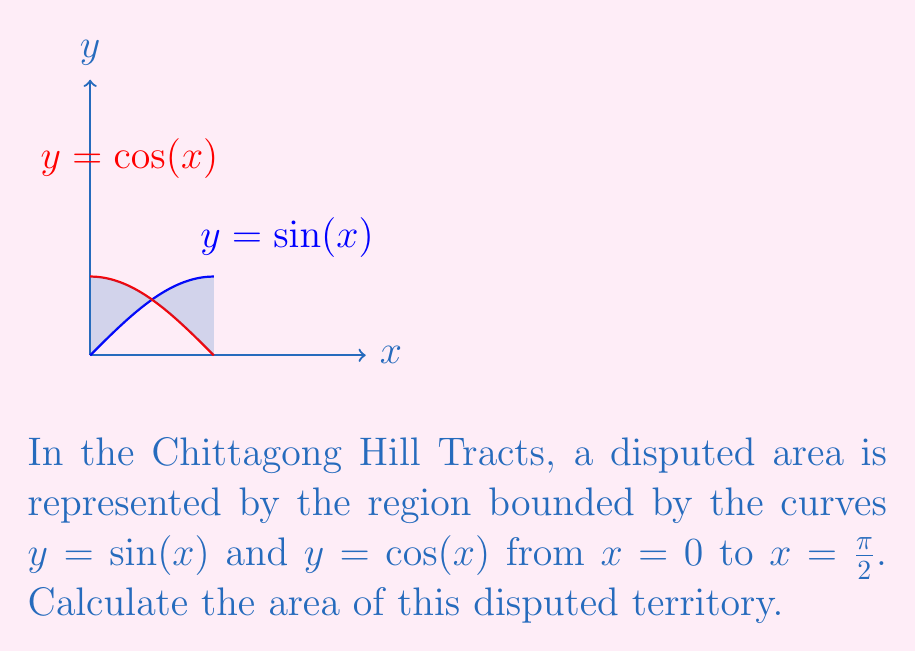Give your solution to this math problem. To find the area of the disputed territory, we need to calculate the definite integral of the difference between the two functions from 0 to $\frac{\pi}{2}$:

1) The area is given by:
   $$A = \int_0^{\frac{\pi}{2}} [\sin(x) - \cos(x)] dx$$

2) To evaluate this integral, we can use the antiderivatives:
   $$\int \sin(x) dx = -\cos(x) + C$$
   $$\int \cos(x) dx = \sin(x) + C$$

3) Applying the Fundamental Theorem of Calculus:
   $$A = [-\cos(x) - \sin(x)]_0^{\frac{\pi}{2}}$$

4) Evaluate at the limits:
   $$A = [-\cos(\frac{\pi}{2}) - \sin(\frac{\pi}{2})] - [-\cos(0) - \sin(0)]$$

5) Simplify:
   $$A = [0 - 1] - [-1 - 0] = -1 + 1 = 0$$

The area evaluates to zero because the regions where $\sin(x)$ is greater than $\cos(x)$ and where $\cos(x)$ is greater than $\sin(x)$ are equal and cancel each other out.
Answer: 0 